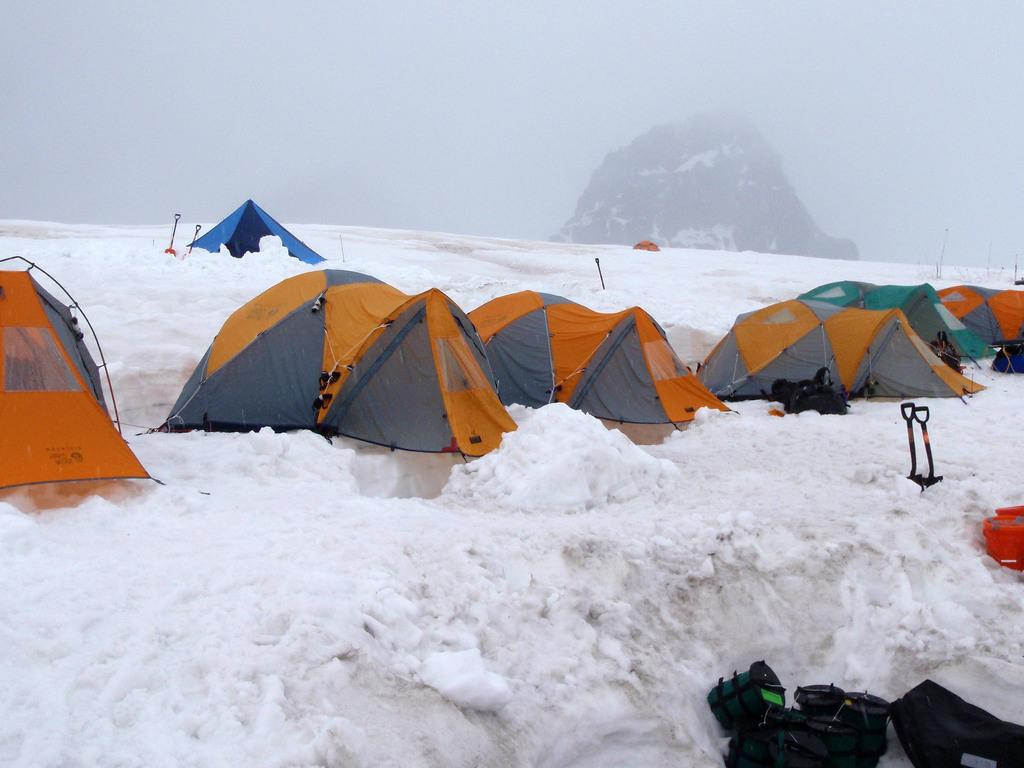What is the condition of the ground in the image? There is snow on the ground in the image. What type of temporary shelters can be seen in the image? There are tents in the image. What tools are visible in the image? There are spades in the image. What can be seen in the background of the image? There is a hill in the background of the image. How is the hill covered in the image? The hill is covered with snow in the image. What type of rabbit can be seen holding a pipe in the image? There is no rabbit or pipe present in the image. What color is the silver object on the hill in the image? There is no silver object present in the image. 